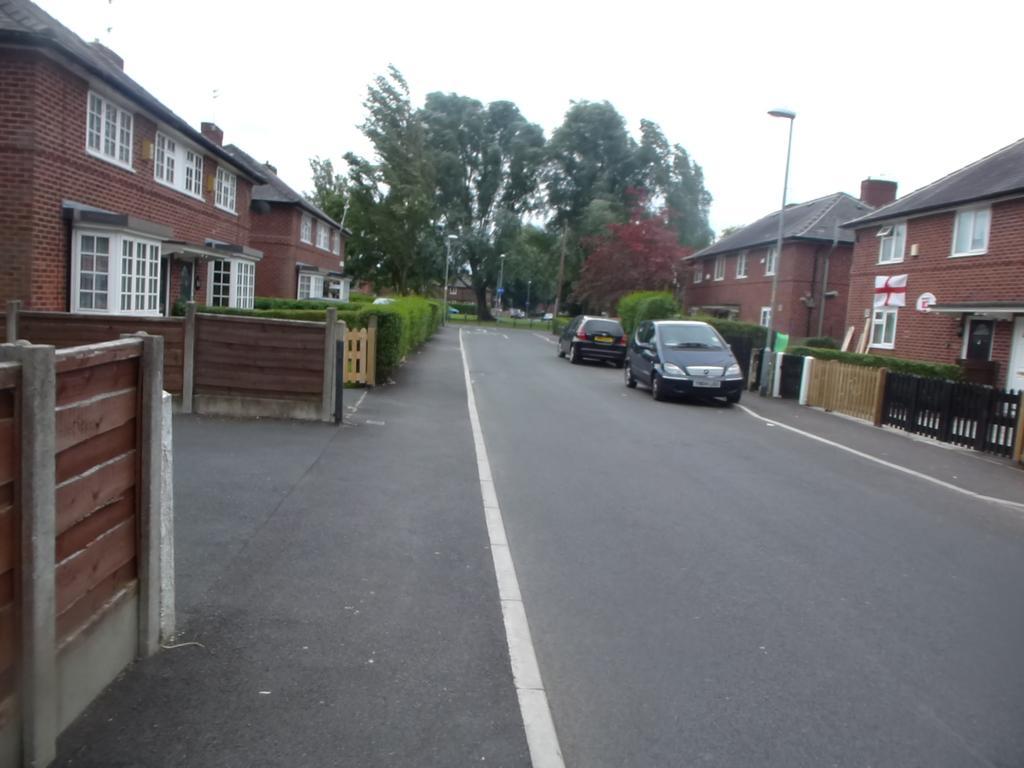In one or two sentences, can you explain what this image depicts? In this image we can see vehicles on the road. On the sides there are buildings with windows, bushes and walls. In the background there are trees and sky. Also there is a light pole. 